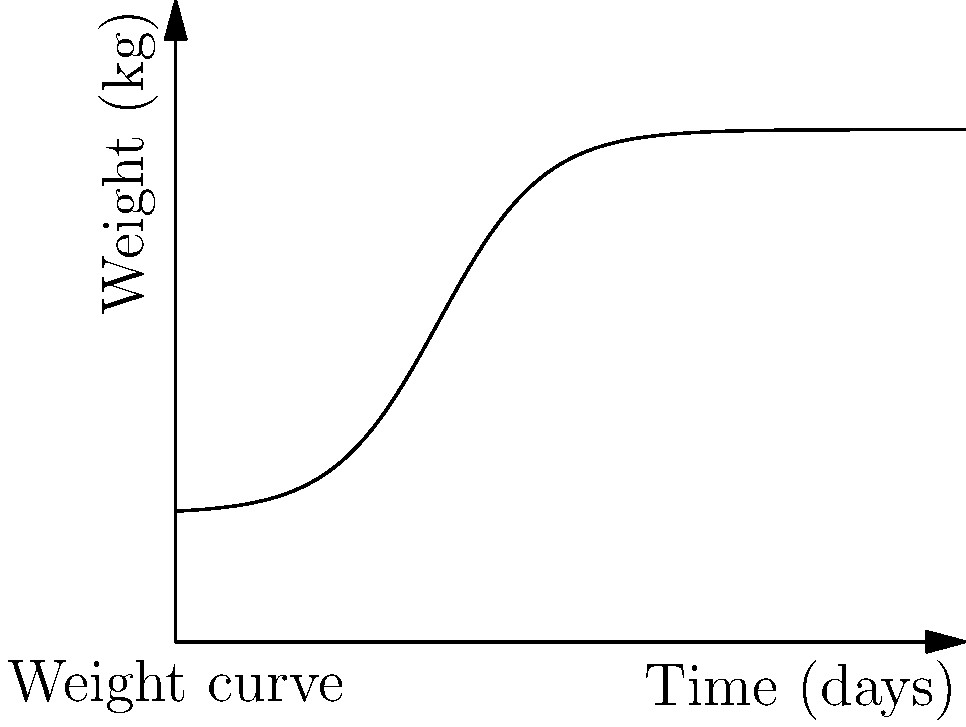A premature infant's weight gain over time follows the curve shown in the graph. Calculate the total weight gain of the infant during the first 30 days using the given function: $f(t) = 0.5 + \frac{1.5}{1 + e^{-0.5(t-10)}}$, where $t$ is time in days and $f(t)$ is weight in kilograms. Round your answer to two decimal places. To calculate the total weight gain, we need to find the difference between the final and initial weights:

1. Initial weight at $t=0$:
   $f(0) = 0.5 + \frac{1.5}{1 + e^{-0.5(0-10)}} = 0.5 + \frac{1.5}{1 + e^5} \approx 0.5137$ kg

2. Final weight at $t=30$:
   $f(30) = 0.5 + \frac{1.5}{1 + e^{-0.5(30-10)}} = 0.5 + \frac{1.5}{1 + e^{-10}} \approx 1.9999$ kg

3. Total weight gain:
   Weight gain = Final weight - Initial weight
   $= 1.9999 - 0.5137 = 1.4862$ kg

Rounding to two decimal places: 1.49 kg
Answer: 1.49 kg 